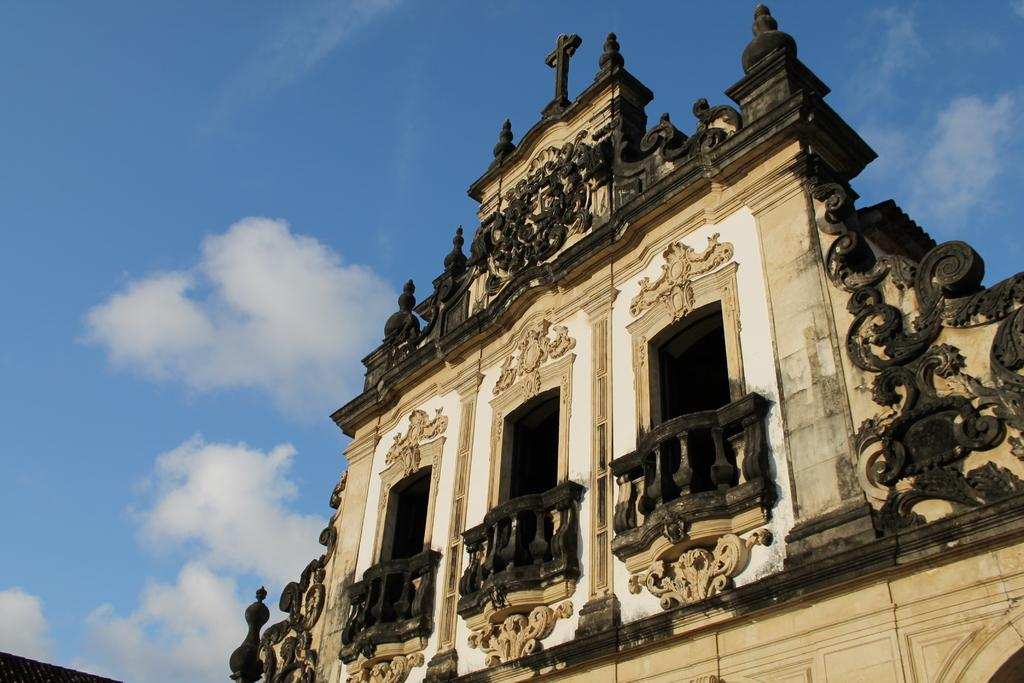What is the person in the image holding? The person is holding a skateboard. Where is the person in the image? The person is in front of a background that is not described in the facts. What is the background of the image? The background of the image is not described in the facts. Can you see any bun in the image? There is no mention of a bun in the image, so it cannot be seen. 